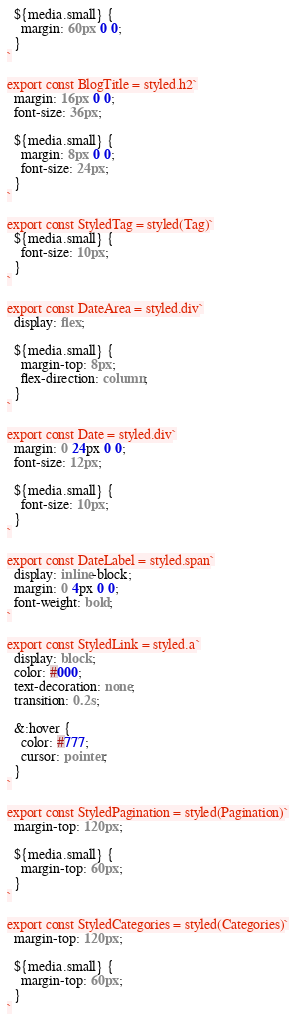Convert code to text. <code><loc_0><loc_0><loc_500><loc_500><_TypeScript_>  ${media.small} {
    margin: 60px 0 0;
  }
`

export const BlogTitle = styled.h2`
  margin: 16px 0 0;
  font-size: 36px;

  ${media.small} {
    margin: 8px 0 0;
    font-size: 24px;
  }
`

export const StyledTag = styled(Tag)`
  ${media.small} {
    font-size: 10px;
  }
`

export const DateArea = styled.div`
  display: flex;

  ${media.small} {
    margin-top: 8px;
    flex-direction: column;
  }
`

export const Date = styled.div`
  margin: 0 24px 0 0;
  font-size: 12px;

  ${media.small} {
    font-size: 10px;
  }
`

export const DateLabel = styled.span`
  display: inline-block;
  margin: 0 4px 0 0;
  font-weight: bold;
`

export const StyledLink = styled.a`
  display: block;
  color: #000;
  text-decoration: none;
  transition: 0.2s;

  &:hover {
    color: #777;
    cursor: pointer;
  }
`

export const StyledPagination = styled(Pagination)`
  margin-top: 120px;

  ${media.small} {
    margin-top: 60px;
  }
`

export const StyledCategories = styled(Categories)`
  margin-top: 120px;

  ${media.small} {
    margin-top: 60px;
  }
`
</code> 